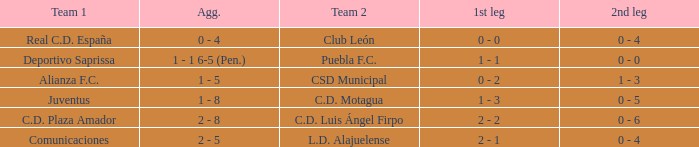What is the 1st leg where Team 1 is C.D. Plaza Amador? 2 - 2. 